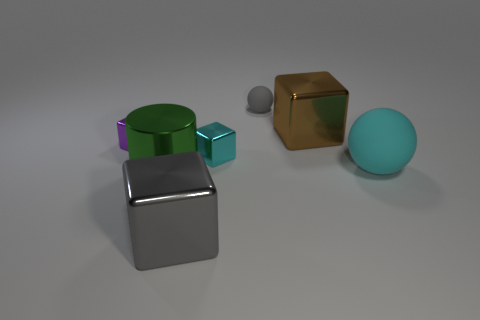Add 2 large gray blocks. How many objects exist? 9 Subtract all balls. How many objects are left? 5 Add 1 green shiny objects. How many green shiny objects are left? 2 Add 1 large brown metallic blocks. How many large brown metallic blocks exist? 2 Subtract 0 red balls. How many objects are left? 7 Subtract all big brown shiny blocks. Subtract all tiny purple shiny balls. How many objects are left? 6 